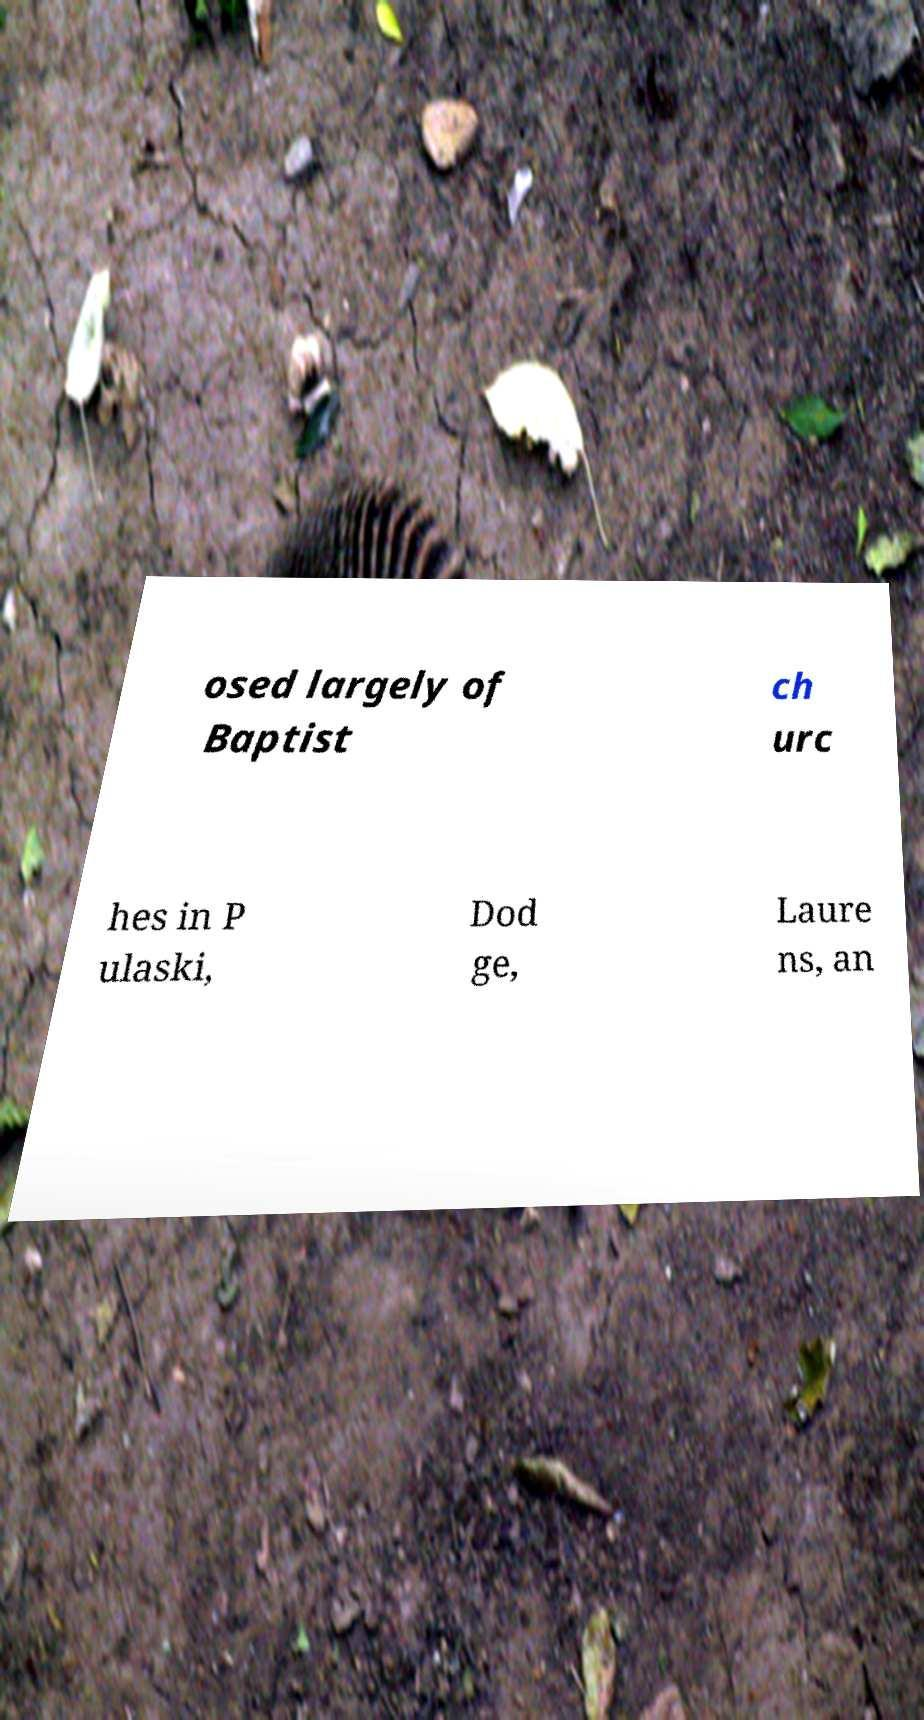Can you read and provide the text displayed in the image?This photo seems to have some interesting text. Can you extract and type it out for me? osed largely of Baptist ch urc hes in P ulaski, Dod ge, Laure ns, an 